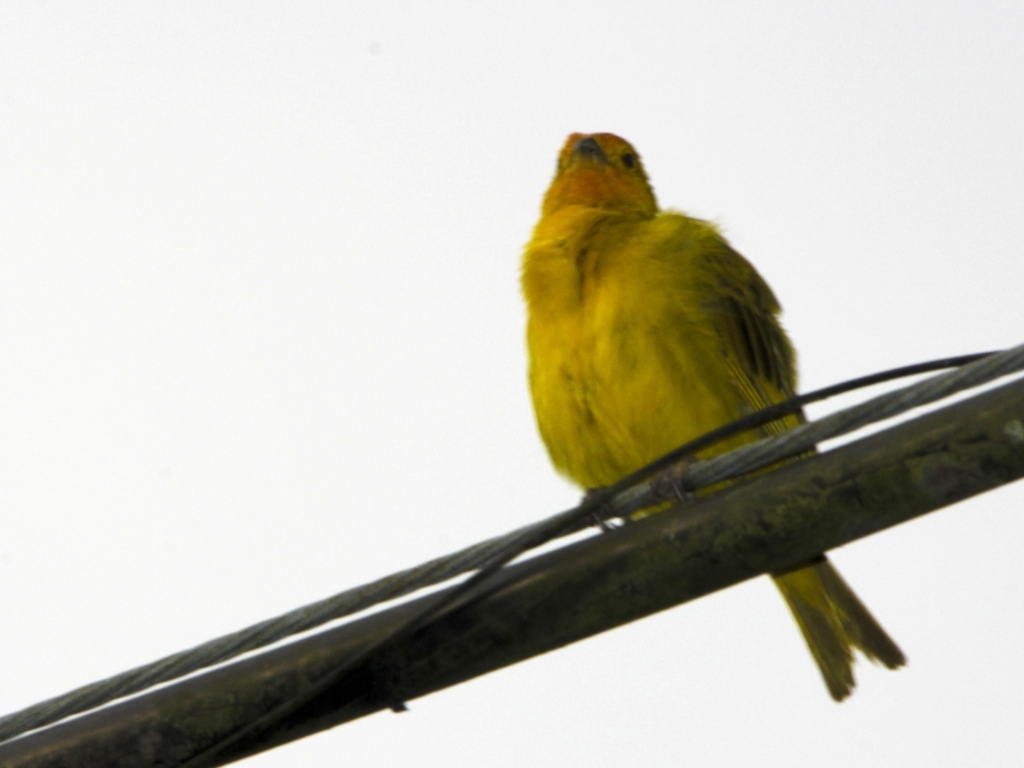How does the image's composition affect its impact on the viewer? The image's composition emphasizes the bird by placing it off-center, adhering to the rule of thirds, which often makes for a more dynamic picture. However, the contrast between the bird's color and the bleak background creates a starkness that can draw the viewer's eye directly to the subject, yet the lack of detail in the background might be seen as a negative to some. 